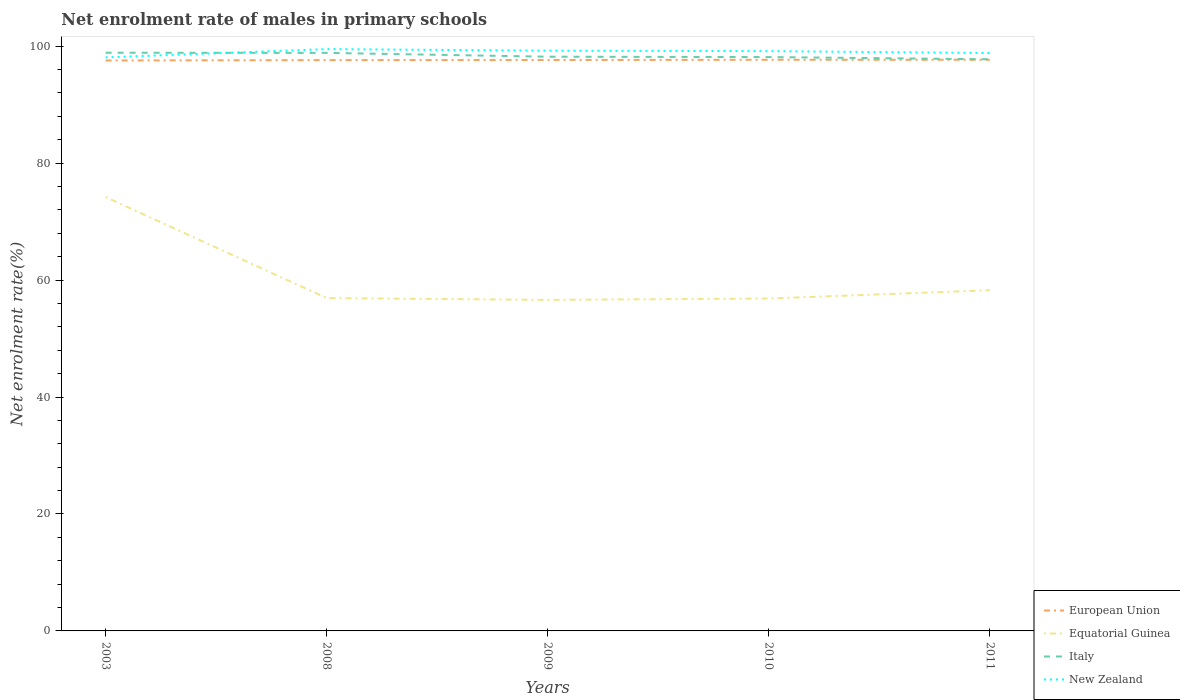Is the number of lines equal to the number of legend labels?
Make the answer very short. Yes. Across all years, what is the maximum net enrolment rate of males in primary schools in New Zealand?
Ensure brevity in your answer.  98.08. What is the total net enrolment rate of males in primary schools in European Union in the graph?
Offer a very short reply. -0.06. What is the difference between the highest and the second highest net enrolment rate of males in primary schools in Italy?
Provide a short and direct response. 1.12. Is the net enrolment rate of males in primary schools in New Zealand strictly greater than the net enrolment rate of males in primary schools in European Union over the years?
Your answer should be very brief. No. How many years are there in the graph?
Provide a succinct answer. 5. Are the values on the major ticks of Y-axis written in scientific E-notation?
Your response must be concise. No. Where does the legend appear in the graph?
Your answer should be compact. Bottom right. How many legend labels are there?
Offer a terse response. 4. How are the legend labels stacked?
Make the answer very short. Vertical. What is the title of the graph?
Ensure brevity in your answer.  Net enrolment rate of males in primary schools. Does "Saudi Arabia" appear as one of the legend labels in the graph?
Your response must be concise. No. What is the label or title of the X-axis?
Provide a succinct answer. Years. What is the label or title of the Y-axis?
Your answer should be compact. Net enrolment rate(%). What is the Net enrolment rate(%) in European Union in 2003?
Make the answer very short. 97.55. What is the Net enrolment rate(%) of Equatorial Guinea in 2003?
Offer a very short reply. 74.2. What is the Net enrolment rate(%) of Italy in 2003?
Make the answer very short. 98.88. What is the Net enrolment rate(%) in New Zealand in 2003?
Keep it short and to the point. 98.08. What is the Net enrolment rate(%) of European Union in 2008?
Your answer should be compact. 97.62. What is the Net enrolment rate(%) in Equatorial Guinea in 2008?
Your response must be concise. 56.92. What is the Net enrolment rate(%) of Italy in 2008?
Your answer should be very brief. 98.85. What is the Net enrolment rate(%) of New Zealand in 2008?
Your answer should be compact. 99.5. What is the Net enrolment rate(%) of European Union in 2009?
Provide a short and direct response. 97.63. What is the Net enrolment rate(%) in Equatorial Guinea in 2009?
Your response must be concise. 56.61. What is the Net enrolment rate(%) in Italy in 2009?
Offer a terse response. 98.2. What is the Net enrolment rate(%) of New Zealand in 2009?
Your response must be concise. 99.23. What is the Net enrolment rate(%) in European Union in 2010?
Offer a very short reply. 97.67. What is the Net enrolment rate(%) of Equatorial Guinea in 2010?
Offer a terse response. 56.85. What is the Net enrolment rate(%) of Italy in 2010?
Offer a terse response. 98.13. What is the Net enrolment rate(%) of New Zealand in 2010?
Give a very brief answer. 99.15. What is the Net enrolment rate(%) of European Union in 2011?
Ensure brevity in your answer.  97.67. What is the Net enrolment rate(%) in Equatorial Guinea in 2011?
Your answer should be very brief. 58.26. What is the Net enrolment rate(%) in Italy in 2011?
Provide a short and direct response. 97.76. What is the Net enrolment rate(%) of New Zealand in 2011?
Provide a short and direct response. 98.83. Across all years, what is the maximum Net enrolment rate(%) of European Union?
Offer a very short reply. 97.67. Across all years, what is the maximum Net enrolment rate(%) in Equatorial Guinea?
Offer a terse response. 74.2. Across all years, what is the maximum Net enrolment rate(%) of Italy?
Make the answer very short. 98.88. Across all years, what is the maximum Net enrolment rate(%) of New Zealand?
Your answer should be very brief. 99.5. Across all years, what is the minimum Net enrolment rate(%) in European Union?
Offer a very short reply. 97.55. Across all years, what is the minimum Net enrolment rate(%) of Equatorial Guinea?
Provide a short and direct response. 56.61. Across all years, what is the minimum Net enrolment rate(%) of Italy?
Make the answer very short. 97.76. Across all years, what is the minimum Net enrolment rate(%) in New Zealand?
Give a very brief answer. 98.08. What is the total Net enrolment rate(%) in European Union in the graph?
Offer a terse response. 488.14. What is the total Net enrolment rate(%) in Equatorial Guinea in the graph?
Offer a very short reply. 302.84. What is the total Net enrolment rate(%) of Italy in the graph?
Provide a short and direct response. 491.82. What is the total Net enrolment rate(%) of New Zealand in the graph?
Offer a terse response. 494.79. What is the difference between the Net enrolment rate(%) in European Union in 2003 and that in 2008?
Your answer should be compact. -0.07. What is the difference between the Net enrolment rate(%) of Equatorial Guinea in 2003 and that in 2008?
Offer a terse response. 17.28. What is the difference between the Net enrolment rate(%) of Italy in 2003 and that in 2008?
Provide a succinct answer. 0.03. What is the difference between the Net enrolment rate(%) of New Zealand in 2003 and that in 2008?
Offer a very short reply. -1.41. What is the difference between the Net enrolment rate(%) in European Union in 2003 and that in 2009?
Ensure brevity in your answer.  -0.08. What is the difference between the Net enrolment rate(%) in Equatorial Guinea in 2003 and that in 2009?
Your answer should be compact. 17.59. What is the difference between the Net enrolment rate(%) in Italy in 2003 and that in 2009?
Offer a terse response. 0.68. What is the difference between the Net enrolment rate(%) in New Zealand in 2003 and that in 2009?
Ensure brevity in your answer.  -1.15. What is the difference between the Net enrolment rate(%) in European Union in 2003 and that in 2010?
Make the answer very short. -0.12. What is the difference between the Net enrolment rate(%) in Equatorial Guinea in 2003 and that in 2010?
Make the answer very short. 17.36. What is the difference between the Net enrolment rate(%) in Italy in 2003 and that in 2010?
Provide a succinct answer. 0.74. What is the difference between the Net enrolment rate(%) of New Zealand in 2003 and that in 2010?
Your answer should be very brief. -1.06. What is the difference between the Net enrolment rate(%) in European Union in 2003 and that in 2011?
Offer a terse response. -0.12. What is the difference between the Net enrolment rate(%) of Equatorial Guinea in 2003 and that in 2011?
Provide a short and direct response. 15.94. What is the difference between the Net enrolment rate(%) in Italy in 2003 and that in 2011?
Offer a very short reply. 1.12. What is the difference between the Net enrolment rate(%) in New Zealand in 2003 and that in 2011?
Your response must be concise. -0.75. What is the difference between the Net enrolment rate(%) in European Union in 2008 and that in 2009?
Your answer should be very brief. -0.01. What is the difference between the Net enrolment rate(%) of Equatorial Guinea in 2008 and that in 2009?
Provide a succinct answer. 0.31. What is the difference between the Net enrolment rate(%) of Italy in 2008 and that in 2009?
Provide a succinct answer. 0.65. What is the difference between the Net enrolment rate(%) of New Zealand in 2008 and that in 2009?
Your response must be concise. 0.27. What is the difference between the Net enrolment rate(%) in European Union in 2008 and that in 2010?
Keep it short and to the point. -0.05. What is the difference between the Net enrolment rate(%) of Equatorial Guinea in 2008 and that in 2010?
Offer a terse response. 0.07. What is the difference between the Net enrolment rate(%) in Italy in 2008 and that in 2010?
Make the answer very short. 0.72. What is the difference between the Net enrolment rate(%) of New Zealand in 2008 and that in 2010?
Provide a short and direct response. 0.35. What is the difference between the Net enrolment rate(%) in European Union in 2008 and that in 2011?
Offer a terse response. -0.06. What is the difference between the Net enrolment rate(%) of Equatorial Guinea in 2008 and that in 2011?
Your answer should be very brief. -1.35. What is the difference between the Net enrolment rate(%) of Italy in 2008 and that in 2011?
Make the answer very short. 1.09. What is the difference between the Net enrolment rate(%) of New Zealand in 2008 and that in 2011?
Give a very brief answer. 0.66. What is the difference between the Net enrolment rate(%) of European Union in 2009 and that in 2010?
Give a very brief answer. -0.04. What is the difference between the Net enrolment rate(%) in Equatorial Guinea in 2009 and that in 2010?
Your answer should be compact. -0.23. What is the difference between the Net enrolment rate(%) in Italy in 2009 and that in 2010?
Make the answer very short. 0.06. What is the difference between the Net enrolment rate(%) of New Zealand in 2009 and that in 2010?
Your answer should be very brief. 0.08. What is the difference between the Net enrolment rate(%) in European Union in 2009 and that in 2011?
Your answer should be compact. -0.04. What is the difference between the Net enrolment rate(%) in Equatorial Guinea in 2009 and that in 2011?
Your response must be concise. -1.65. What is the difference between the Net enrolment rate(%) of Italy in 2009 and that in 2011?
Your answer should be very brief. 0.44. What is the difference between the Net enrolment rate(%) in New Zealand in 2009 and that in 2011?
Give a very brief answer. 0.4. What is the difference between the Net enrolment rate(%) of European Union in 2010 and that in 2011?
Your response must be concise. -0. What is the difference between the Net enrolment rate(%) in Equatorial Guinea in 2010 and that in 2011?
Offer a very short reply. -1.42. What is the difference between the Net enrolment rate(%) of Italy in 2010 and that in 2011?
Your answer should be very brief. 0.37. What is the difference between the Net enrolment rate(%) of New Zealand in 2010 and that in 2011?
Make the answer very short. 0.32. What is the difference between the Net enrolment rate(%) of European Union in 2003 and the Net enrolment rate(%) of Equatorial Guinea in 2008?
Ensure brevity in your answer.  40.63. What is the difference between the Net enrolment rate(%) in European Union in 2003 and the Net enrolment rate(%) in Italy in 2008?
Your answer should be compact. -1.3. What is the difference between the Net enrolment rate(%) in European Union in 2003 and the Net enrolment rate(%) in New Zealand in 2008?
Make the answer very short. -1.95. What is the difference between the Net enrolment rate(%) of Equatorial Guinea in 2003 and the Net enrolment rate(%) of Italy in 2008?
Make the answer very short. -24.65. What is the difference between the Net enrolment rate(%) in Equatorial Guinea in 2003 and the Net enrolment rate(%) in New Zealand in 2008?
Keep it short and to the point. -25.3. What is the difference between the Net enrolment rate(%) of Italy in 2003 and the Net enrolment rate(%) of New Zealand in 2008?
Your answer should be compact. -0.62. What is the difference between the Net enrolment rate(%) in European Union in 2003 and the Net enrolment rate(%) in Equatorial Guinea in 2009?
Your answer should be very brief. 40.94. What is the difference between the Net enrolment rate(%) of European Union in 2003 and the Net enrolment rate(%) of Italy in 2009?
Keep it short and to the point. -0.65. What is the difference between the Net enrolment rate(%) of European Union in 2003 and the Net enrolment rate(%) of New Zealand in 2009?
Make the answer very short. -1.68. What is the difference between the Net enrolment rate(%) in Equatorial Guinea in 2003 and the Net enrolment rate(%) in Italy in 2009?
Offer a very short reply. -24. What is the difference between the Net enrolment rate(%) of Equatorial Guinea in 2003 and the Net enrolment rate(%) of New Zealand in 2009?
Your answer should be compact. -25.03. What is the difference between the Net enrolment rate(%) in Italy in 2003 and the Net enrolment rate(%) in New Zealand in 2009?
Give a very brief answer. -0.35. What is the difference between the Net enrolment rate(%) in European Union in 2003 and the Net enrolment rate(%) in Equatorial Guinea in 2010?
Your answer should be compact. 40.71. What is the difference between the Net enrolment rate(%) in European Union in 2003 and the Net enrolment rate(%) in Italy in 2010?
Make the answer very short. -0.58. What is the difference between the Net enrolment rate(%) in European Union in 2003 and the Net enrolment rate(%) in New Zealand in 2010?
Offer a very short reply. -1.6. What is the difference between the Net enrolment rate(%) of Equatorial Guinea in 2003 and the Net enrolment rate(%) of Italy in 2010?
Keep it short and to the point. -23.93. What is the difference between the Net enrolment rate(%) in Equatorial Guinea in 2003 and the Net enrolment rate(%) in New Zealand in 2010?
Give a very brief answer. -24.95. What is the difference between the Net enrolment rate(%) of Italy in 2003 and the Net enrolment rate(%) of New Zealand in 2010?
Your answer should be compact. -0.27. What is the difference between the Net enrolment rate(%) in European Union in 2003 and the Net enrolment rate(%) in Equatorial Guinea in 2011?
Your answer should be compact. 39.29. What is the difference between the Net enrolment rate(%) of European Union in 2003 and the Net enrolment rate(%) of Italy in 2011?
Your answer should be compact. -0.21. What is the difference between the Net enrolment rate(%) of European Union in 2003 and the Net enrolment rate(%) of New Zealand in 2011?
Offer a very short reply. -1.28. What is the difference between the Net enrolment rate(%) in Equatorial Guinea in 2003 and the Net enrolment rate(%) in Italy in 2011?
Provide a short and direct response. -23.56. What is the difference between the Net enrolment rate(%) of Equatorial Guinea in 2003 and the Net enrolment rate(%) of New Zealand in 2011?
Your answer should be very brief. -24.63. What is the difference between the Net enrolment rate(%) of Italy in 2003 and the Net enrolment rate(%) of New Zealand in 2011?
Provide a succinct answer. 0.05. What is the difference between the Net enrolment rate(%) in European Union in 2008 and the Net enrolment rate(%) in Equatorial Guinea in 2009?
Ensure brevity in your answer.  41.01. What is the difference between the Net enrolment rate(%) in European Union in 2008 and the Net enrolment rate(%) in Italy in 2009?
Give a very brief answer. -0.58. What is the difference between the Net enrolment rate(%) of European Union in 2008 and the Net enrolment rate(%) of New Zealand in 2009?
Provide a succinct answer. -1.61. What is the difference between the Net enrolment rate(%) in Equatorial Guinea in 2008 and the Net enrolment rate(%) in Italy in 2009?
Keep it short and to the point. -41.28. What is the difference between the Net enrolment rate(%) in Equatorial Guinea in 2008 and the Net enrolment rate(%) in New Zealand in 2009?
Offer a terse response. -42.31. What is the difference between the Net enrolment rate(%) of Italy in 2008 and the Net enrolment rate(%) of New Zealand in 2009?
Your answer should be compact. -0.38. What is the difference between the Net enrolment rate(%) in European Union in 2008 and the Net enrolment rate(%) in Equatorial Guinea in 2010?
Provide a short and direct response. 40.77. What is the difference between the Net enrolment rate(%) in European Union in 2008 and the Net enrolment rate(%) in Italy in 2010?
Make the answer very short. -0.52. What is the difference between the Net enrolment rate(%) in European Union in 2008 and the Net enrolment rate(%) in New Zealand in 2010?
Your response must be concise. -1.53. What is the difference between the Net enrolment rate(%) in Equatorial Guinea in 2008 and the Net enrolment rate(%) in Italy in 2010?
Offer a very short reply. -41.22. What is the difference between the Net enrolment rate(%) of Equatorial Guinea in 2008 and the Net enrolment rate(%) of New Zealand in 2010?
Provide a succinct answer. -42.23. What is the difference between the Net enrolment rate(%) of Italy in 2008 and the Net enrolment rate(%) of New Zealand in 2010?
Give a very brief answer. -0.3. What is the difference between the Net enrolment rate(%) in European Union in 2008 and the Net enrolment rate(%) in Equatorial Guinea in 2011?
Offer a terse response. 39.35. What is the difference between the Net enrolment rate(%) of European Union in 2008 and the Net enrolment rate(%) of Italy in 2011?
Provide a succinct answer. -0.14. What is the difference between the Net enrolment rate(%) of European Union in 2008 and the Net enrolment rate(%) of New Zealand in 2011?
Provide a short and direct response. -1.22. What is the difference between the Net enrolment rate(%) in Equatorial Guinea in 2008 and the Net enrolment rate(%) in Italy in 2011?
Offer a terse response. -40.84. What is the difference between the Net enrolment rate(%) of Equatorial Guinea in 2008 and the Net enrolment rate(%) of New Zealand in 2011?
Offer a very short reply. -41.91. What is the difference between the Net enrolment rate(%) in Italy in 2008 and the Net enrolment rate(%) in New Zealand in 2011?
Make the answer very short. 0.02. What is the difference between the Net enrolment rate(%) of European Union in 2009 and the Net enrolment rate(%) of Equatorial Guinea in 2010?
Your answer should be very brief. 40.78. What is the difference between the Net enrolment rate(%) in European Union in 2009 and the Net enrolment rate(%) in Italy in 2010?
Offer a very short reply. -0.5. What is the difference between the Net enrolment rate(%) in European Union in 2009 and the Net enrolment rate(%) in New Zealand in 2010?
Provide a short and direct response. -1.52. What is the difference between the Net enrolment rate(%) in Equatorial Guinea in 2009 and the Net enrolment rate(%) in Italy in 2010?
Your answer should be very brief. -41.52. What is the difference between the Net enrolment rate(%) of Equatorial Guinea in 2009 and the Net enrolment rate(%) of New Zealand in 2010?
Give a very brief answer. -42.54. What is the difference between the Net enrolment rate(%) in Italy in 2009 and the Net enrolment rate(%) in New Zealand in 2010?
Give a very brief answer. -0.95. What is the difference between the Net enrolment rate(%) of European Union in 2009 and the Net enrolment rate(%) of Equatorial Guinea in 2011?
Offer a very short reply. 39.37. What is the difference between the Net enrolment rate(%) of European Union in 2009 and the Net enrolment rate(%) of Italy in 2011?
Make the answer very short. -0.13. What is the difference between the Net enrolment rate(%) in European Union in 2009 and the Net enrolment rate(%) in New Zealand in 2011?
Keep it short and to the point. -1.2. What is the difference between the Net enrolment rate(%) of Equatorial Guinea in 2009 and the Net enrolment rate(%) of Italy in 2011?
Make the answer very short. -41.15. What is the difference between the Net enrolment rate(%) in Equatorial Guinea in 2009 and the Net enrolment rate(%) in New Zealand in 2011?
Your answer should be very brief. -42.22. What is the difference between the Net enrolment rate(%) in Italy in 2009 and the Net enrolment rate(%) in New Zealand in 2011?
Provide a short and direct response. -0.64. What is the difference between the Net enrolment rate(%) of European Union in 2010 and the Net enrolment rate(%) of Equatorial Guinea in 2011?
Offer a very short reply. 39.41. What is the difference between the Net enrolment rate(%) of European Union in 2010 and the Net enrolment rate(%) of Italy in 2011?
Keep it short and to the point. -0.09. What is the difference between the Net enrolment rate(%) in European Union in 2010 and the Net enrolment rate(%) in New Zealand in 2011?
Your response must be concise. -1.16. What is the difference between the Net enrolment rate(%) of Equatorial Guinea in 2010 and the Net enrolment rate(%) of Italy in 2011?
Offer a terse response. -40.91. What is the difference between the Net enrolment rate(%) of Equatorial Guinea in 2010 and the Net enrolment rate(%) of New Zealand in 2011?
Give a very brief answer. -41.99. What is the difference between the Net enrolment rate(%) in Italy in 2010 and the Net enrolment rate(%) in New Zealand in 2011?
Make the answer very short. -0.7. What is the average Net enrolment rate(%) of European Union per year?
Provide a succinct answer. 97.63. What is the average Net enrolment rate(%) of Equatorial Guinea per year?
Your answer should be compact. 60.57. What is the average Net enrolment rate(%) of Italy per year?
Offer a terse response. 98.36. What is the average Net enrolment rate(%) in New Zealand per year?
Your answer should be very brief. 98.96. In the year 2003, what is the difference between the Net enrolment rate(%) of European Union and Net enrolment rate(%) of Equatorial Guinea?
Provide a short and direct response. 23.35. In the year 2003, what is the difference between the Net enrolment rate(%) in European Union and Net enrolment rate(%) in Italy?
Your answer should be compact. -1.33. In the year 2003, what is the difference between the Net enrolment rate(%) of European Union and Net enrolment rate(%) of New Zealand?
Offer a terse response. -0.53. In the year 2003, what is the difference between the Net enrolment rate(%) of Equatorial Guinea and Net enrolment rate(%) of Italy?
Make the answer very short. -24.68. In the year 2003, what is the difference between the Net enrolment rate(%) of Equatorial Guinea and Net enrolment rate(%) of New Zealand?
Make the answer very short. -23.88. In the year 2003, what is the difference between the Net enrolment rate(%) of Italy and Net enrolment rate(%) of New Zealand?
Provide a short and direct response. 0.79. In the year 2008, what is the difference between the Net enrolment rate(%) in European Union and Net enrolment rate(%) in Equatorial Guinea?
Provide a short and direct response. 40.7. In the year 2008, what is the difference between the Net enrolment rate(%) of European Union and Net enrolment rate(%) of Italy?
Keep it short and to the point. -1.23. In the year 2008, what is the difference between the Net enrolment rate(%) of European Union and Net enrolment rate(%) of New Zealand?
Keep it short and to the point. -1.88. In the year 2008, what is the difference between the Net enrolment rate(%) in Equatorial Guinea and Net enrolment rate(%) in Italy?
Give a very brief answer. -41.93. In the year 2008, what is the difference between the Net enrolment rate(%) of Equatorial Guinea and Net enrolment rate(%) of New Zealand?
Offer a very short reply. -42.58. In the year 2008, what is the difference between the Net enrolment rate(%) in Italy and Net enrolment rate(%) in New Zealand?
Give a very brief answer. -0.64. In the year 2009, what is the difference between the Net enrolment rate(%) of European Union and Net enrolment rate(%) of Equatorial Guinea?
Keep it short and to the point. 41.02. In the year 2009, what is the difference between the Net enrolment rate(%) in European Union and Net enrolment rate(%) in Italy?
Provide a short and direct response. -0.57. In the year 2009, what is the difference between the Net enrolment rate(%) of European Union and Net enrolment rate(%) of New Zealand?
Provide a succinct answer. -1.6. In the year 2009, what is the difference between the Net enrolment rate(%) in Equatorial Guinea and Net enrolment rate(%) in Italy?
Provide a succinct answer. -41.59. In the year 2009, what is the difference between the Net enrolment rate(%) in Equatorial Guinea and Net enrolment rate(%) in New Zealand?
Provide a succinct answer. -42.62. In the year 2009, what is the difference between the Net enrolment rate(%) in Italy and Net enrolment rate(%) in New Zealand?
Make the answer very short. -1.03. In the year 2010, what is the difference between the Net enrolment rate(%) of European Union and Net enrolment rate(%) of Equatorial Guinea?
Ensure brevity in your answer.  40.83. In the year 2010, what is the difference between the Net enrolment rate(%) in European Union and Net enrolment rate(%) in Italy?
Your answer should be very brief. -0.46. In the year 2010, what is the difference between the Net enrolment rate(%) of European Union and Net enrolment rate(%) of New Zealand?
Provide a succinct answer. -1.48. In the year 2010, what is the difference between the Net enrolment rate(%) in Equatorial Guinea and Net enrolment rate(%) in Italy?
Ensure brevity in your answer.  -41.29. In the year 2010, what is the difference between the Net enrolment rate(%) of Equatorial Guinea and Net enrolment rate(%) of New Zealand?
Provide a succinct answer. -42.3. In the year 2010, what is the difference between the Net enrolment rate(%) in Italy and Net enrolment rate(%) in New Zealand?
Your answer should be very brief. -1.01. In the year 2011, what is the difference between the Net enrolment rate(%) of European Union and Net enrolment rate(%) of Equatorial Guinea?
Provide a short and direct response. 39.41. In the year 2011, what is the difference between the Net enrolment rate(%) of European Union and Net enrolment rate(%) of Italy?
Make the answer very short. -0.09. In the year 2011, what is the difference between the Net enrolment rate(%) in European Union and Net enrolment rate(%) in New Zealand?
Your answer should be compact. -1.16. In the year 2011, what is the difference between the Net enrolment rate(%) of Equatorial Guinea and Net enrolment rate(%) of Italy?
Offer a terse response. -39.5. In the year 2011, what is the difference between the Net enrolment rate(%) of Equatorial Guinea and Net enrolment rate(%) of New Zealand?
Provide a short and direct response. -40.57. In the year 2011, what is the difference between the Net enrolment rate(%) of Italy and Net enrolment rate(%) of New Zealand?
Give a very brief answer. -1.07. What is the ratio of the Net enrolment rate(%) in Equatorial Guinea in 2003 to that in 2008?
Ensure brevity in your answer.  1.3. What is the ratio of the Net enrolment rate(%) in New Zealand in 2003 to that in 2008?
Give a very brief answer. 0.99. What is the ratio of the Net enrolment rate(%) of Equatorial Guinea in 2003 to that in 2009?
Make the answer very short. 1.31. What is the ratio of the Net enrolment rate(%) of New Zealand in 2003 to that in 2009?
Give a very brief answer. 0.99. What is the ratio of the Net enrolment rate(%) of Equatorial Guinea in 2003 to that in 2010?
Your answer should be very brief. 1.31. What is the ratio of the Net enrolment rate(%) of Italy in 2003 to that in 2010?
Your answer should be very brief. 1.01. What is the ratio of the Net enrolment rate(%) in New Zealand in 2003 to that in 2010?
Keep it short and to the point. 0.99. What is the ratio of the Net enrolment rate(%) in European Union in 2003 to that in 2011?
Make the answer very short. 1. What is the ratio of the Net enrolment rate(%) in Equatorial Guinea in 2003 to that in 2011?
Your response must be concise. 1.27. What is the ratio of the Net enrolment rate(%) in Italy in 2003 to that in 2011?
Offer a terse response. 1.01. What is the ratio of the Net enrolment rate(%) of New Zealand in 2003 to that in 2011?
Your response must be concise. 0.99. What is the ratio of the Net enrolment rate(%) in Equatorial Guinea in 2008 to that in 2009?
Provide a short and direct response. 1.01. What is the ratio of the Net enrolment rate(%) of Italy in 2008 to that in 2009?
Your response must be concise. 1.01. What is the ratio of the Net enrolment rate(%) of Italy in 2008 to that in 2010?
Provide a short and direct response. 1.01. What is the ratio of the Net enrolment rate(%) in New Zealand in 2008 to that in 2010?
Offer a terse response. 1. What is the ratio of the Net enrolment rate(%) of Equatorial Guinea in 2008 to that in 2011?
Your answer should be very brief. 0.98. What is the ratio of the Net enrolment rate(%) of Italy in 2008 to that in 2011?
Keep it short and to the point. 1.01. What is the ratio of the Net enrolment rate(%) of New Zealand in 2008 to that in 2011?
Your answer should be compact. 1.01. What is the ratio of the Net enrolment rate(%) in Equatorial Guinea in 2009 to that in 2010?
Your response must be concise. 1. What is the ratio of the Net enrolment rate(%) of Italy in 2009 to that in 2010?
Your answer should be compact. 1. What is the ratio of the Net enrolment rate(%) in European Union in 2009 to that in 2011?
Offer a very short reply. 1. What is the ratio of the Net enrolment rate(%) of Equatorial Guinea in 2009 to that in 2011?
Offer a terse response. 0.97. What is the ratio of the Net enrolment rate(%) of European Union in 2010 to that in 2011?
Make the answer very short. 1. What is the ratio of the Net enrolment rate(%) of Equatorial Guinea in 2010 to that in 2011?
Offer a terse response. 0.98. What is the ratio of the Net enrolment rate(%) of New Zealand in 2010 to that in 2011?
Offer a very short reply. 1. What is the difference between the highest and the second highest Net enrolment rate(%) of European Union?
Provide a short and direct response. 0. What is the difference between the highest and the second highest Net enrolment rate(%) of Equatorial Guinea?
Your answer should be compact. 15.94. What is the difference between the highest and the second highest Net enrolment rate(%) of Italy?
Give a very brief answer. 0.03. What is the difference between the highest and the second highest Net enrolment rate(%) of New Zealand?
Provide a succinct answer. 0.27. What is the difference between the highest and the lowest Net enrolment rate(%) in European Union?
Your answer should be compact. 0.12. What is the difference between the highest and the lowest Net enrolment rate(%) of Equatorial Guinea?
Offer a terse response. 17.59. What is the difference between the highest and the lowest Net enrolment rate(%) of Italy?
Provide a short and direct response. 1.12. What is the difference between the highest and the lowest Net enrolment rate(%) in New Zealand?
Your answer should be very brief. 1.41. 